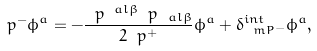<formula> <loc_0><loc_0><loc_500><loc_500>\ p ^ { - } \phi ^ { a } = - \frac { \ p ^ { \ a l \beta } \ p _ { \ a l \beta } } { 2 \ p ^ { + } } \phi ^ { a } + \delta ^ { i n t } _ { \ m P ^ { - } } \phi ^ { a } ,</formula> 